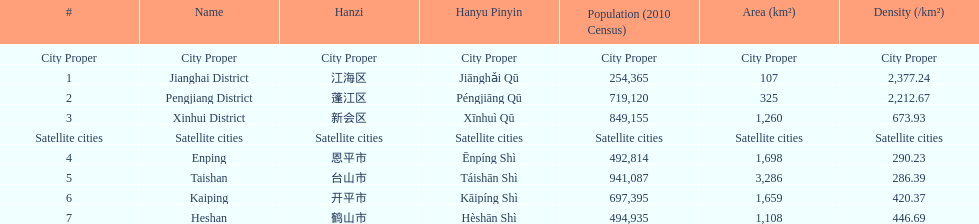Is enping denser/less dense compared to kaiping? Less. 